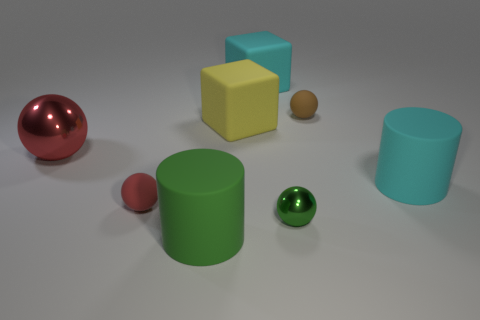Add 1 large yellow blocks. How many objects exist? 9 Subtract all large balls. How many balls are left? 3 Subtract all brown spheres. How many spheres are left? 3 Subtract all cylinders. How many objects are left? 6 Subtract 2 balls. How many balls are left? 2 Subtract all purple cylinders. Subtract all brown blocks. How many cylinders are left? 2 Subtract all green cylinders. How many red spheres are left? 2 Subtract all big blue objects. Subtract all large green objects. How many objects are left? 7 Add 1 small matte things. How many small matte things are left? 3 Add 2 big cyan matte blocks. How many big cyan matte blocks exist? 3 